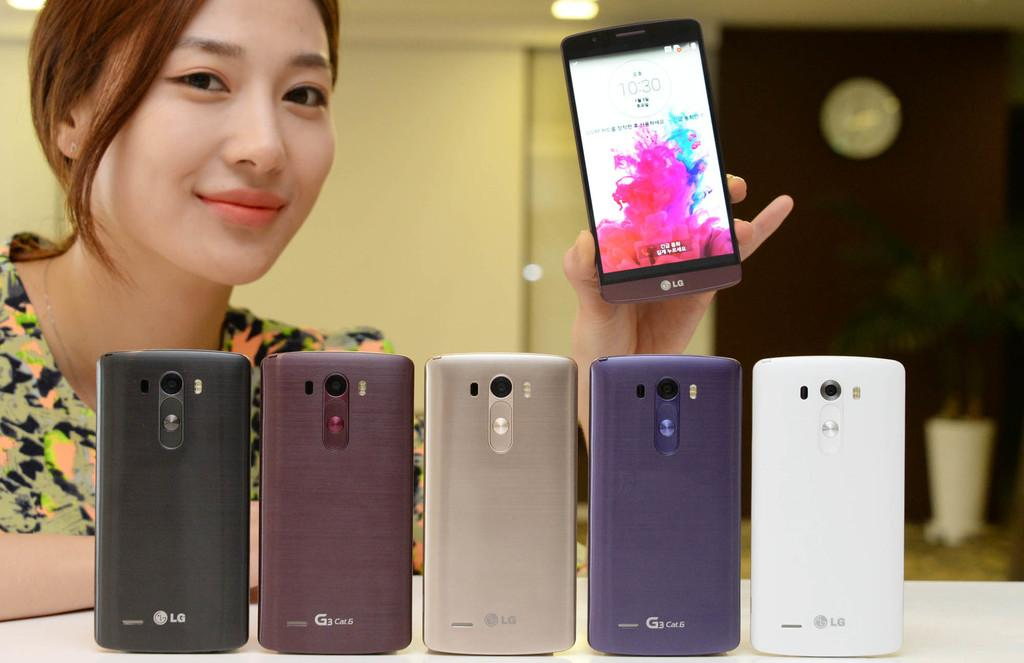<image>
Summarize the visual content of the image. A woman holds up a phone that is displaying a time of 10:30 